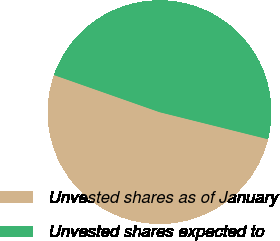Convert chart to OTSL. <chart><loc_0><loc_0><loc_500><loc_500><pie_chart><fcel>Unvested shares as of January<fcel>Unvested shares expected to<nl><fcel>51.49%<fcel>48.51%<nl></chart> 